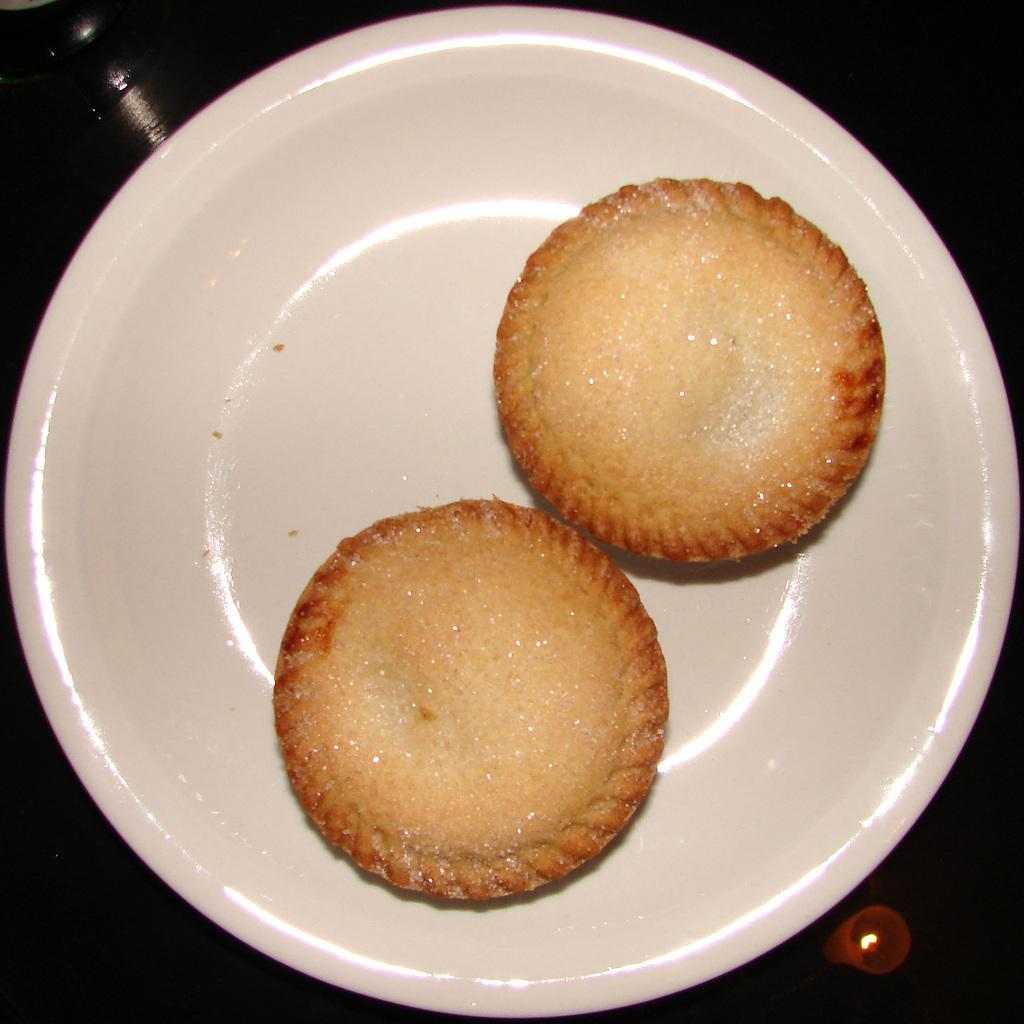What piece of furniture is present in the image? There is a table in the image. What is placed on the table? There is a plate on the table. What is on the plate? The plate contains cookies. What type of agreement is being discussed at the table in the image? There is no indication of any agreement being discussed in the image; it only shows a table with a plate of cookies. 